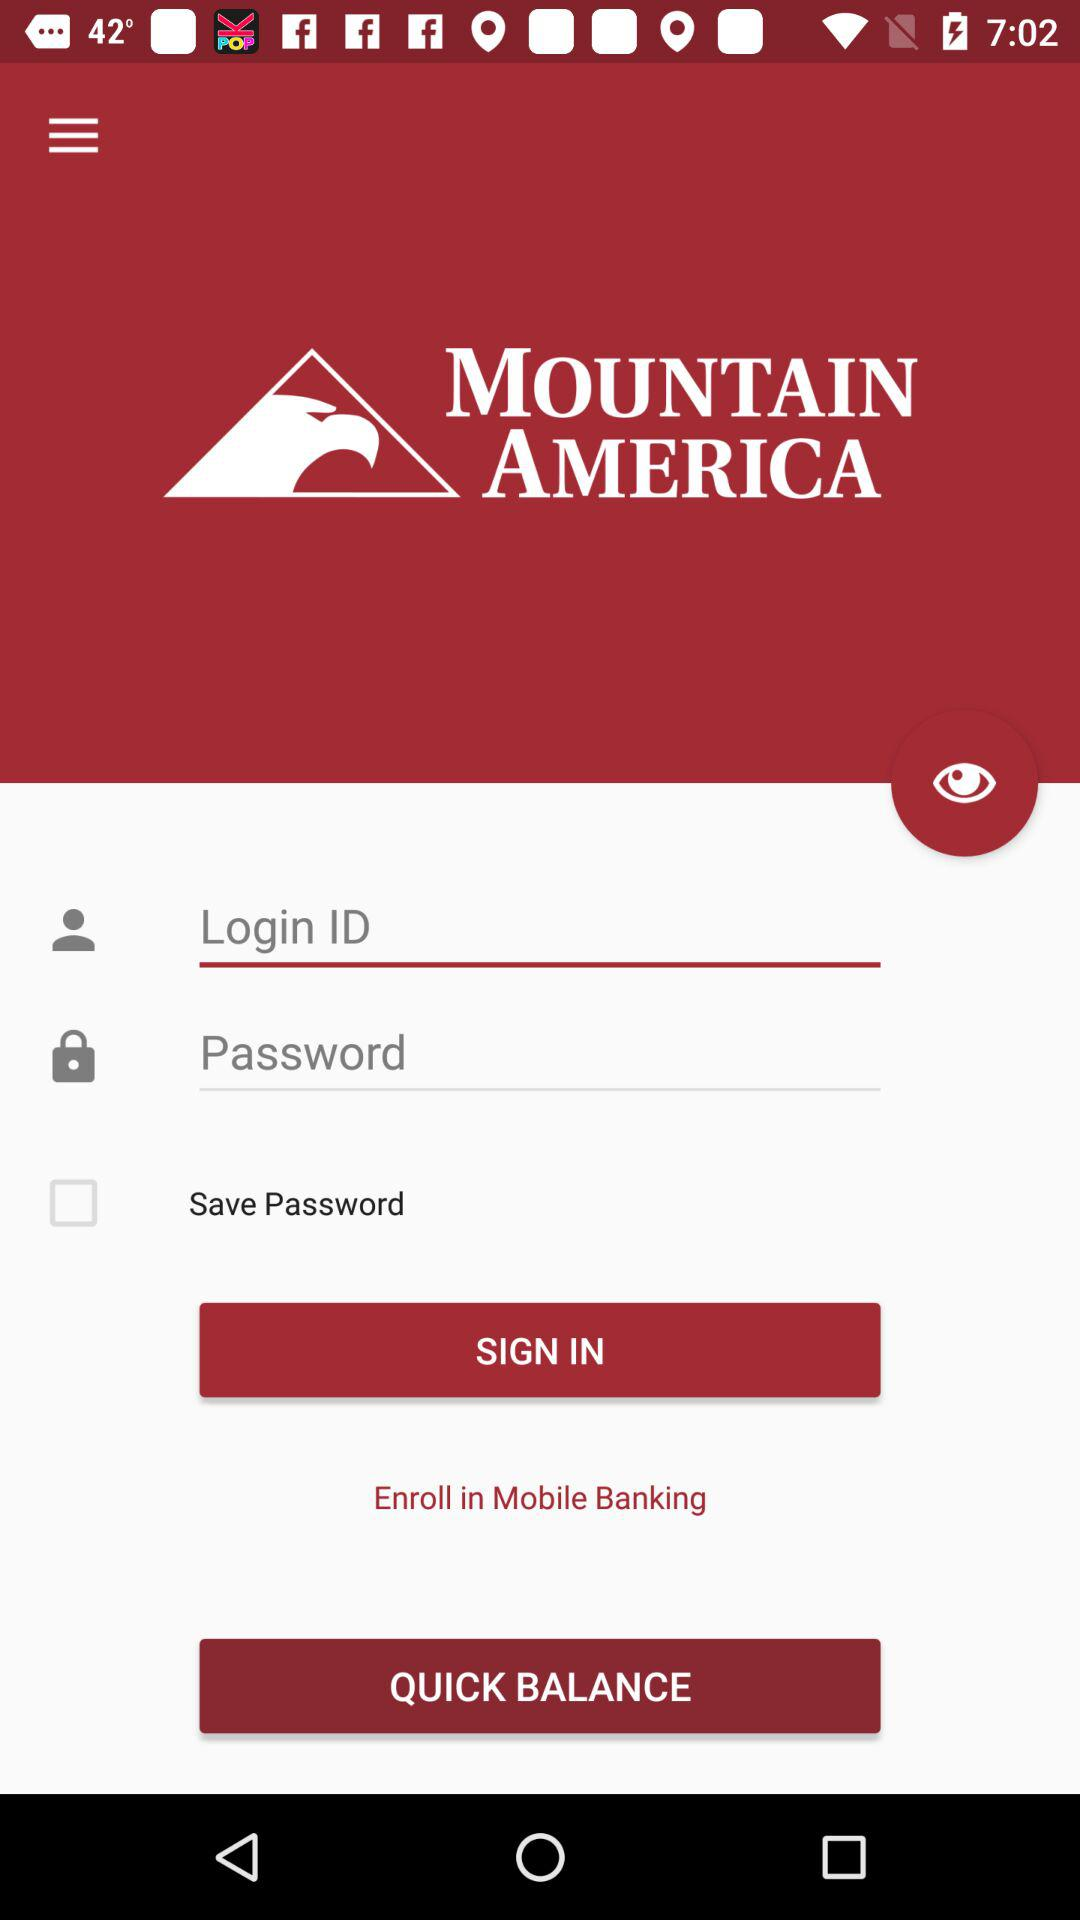How many fields are there to enter credentials?
Answer the question using a single word or phrase. 2 